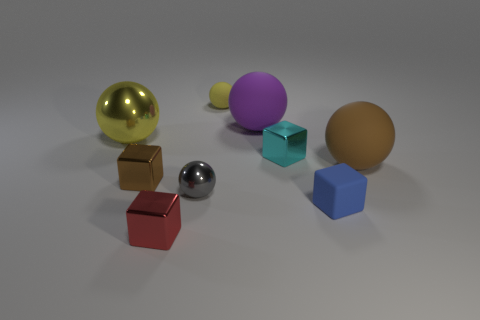Is the number of tiny brown shiny blocks greater than the number of big green matte blocks?
Your answer should be very brief. Yes. Is there any other thing of the same color as the large shiny object?
Offer a very short reply. Yes. There is a yellow object that is made of the same material as the tiny blue block; what is its size?
Keep it short and to the point. Small. What is the material of the purple sphere?
Provide a succinct answer. Rubber. How many other matte balls have the same size as the brown sphere?
Offer a terse response. 1. There is a thing that is the same color as the large metallic sphere; what shape is it?
Provide a short and direct response. Sphere. Is there a yellow object of the same shape as the blue rubber object?
Your answer should be compact. No. What color is the sphere that is the same size as the yellow rubber thing?
Your answer should be compact. Gray. There is a metal block in front of the shiny block that is on the left side of the red shiny thing; what color is it?
Offer a terse response. Red. There is a large object that is to the left of the brown metal object; does it have the same color as the tiny matte ball?
Give a very brief answer. Yes. 